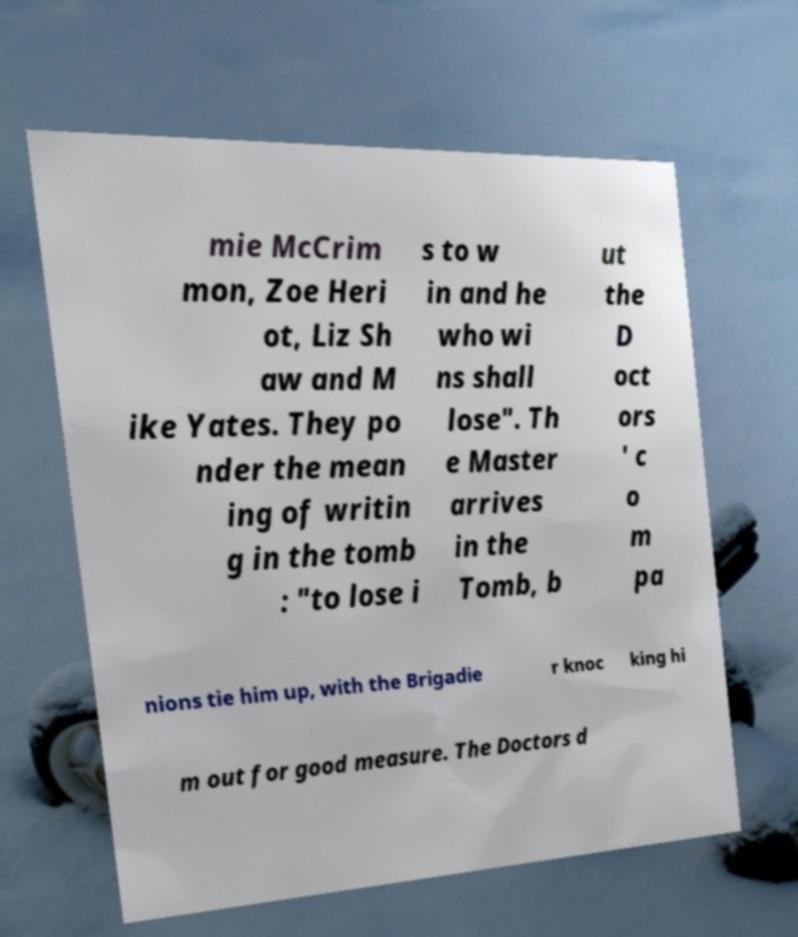Please read and relay the text visible in this image. What does it say? mie McCrim mon, Zoe Heri ot, Liz Sh aw and M ike Yates. They po nder the mean ing of writin g in the tomb : "to lose i s to w in and he who wi ns shall lose". Th e Master arrives in the Tomb, b ut the D oct ors ' c o m pa nions tie him up, with the Brigadie r knoc king hi m out for good measure. The Doctors d 